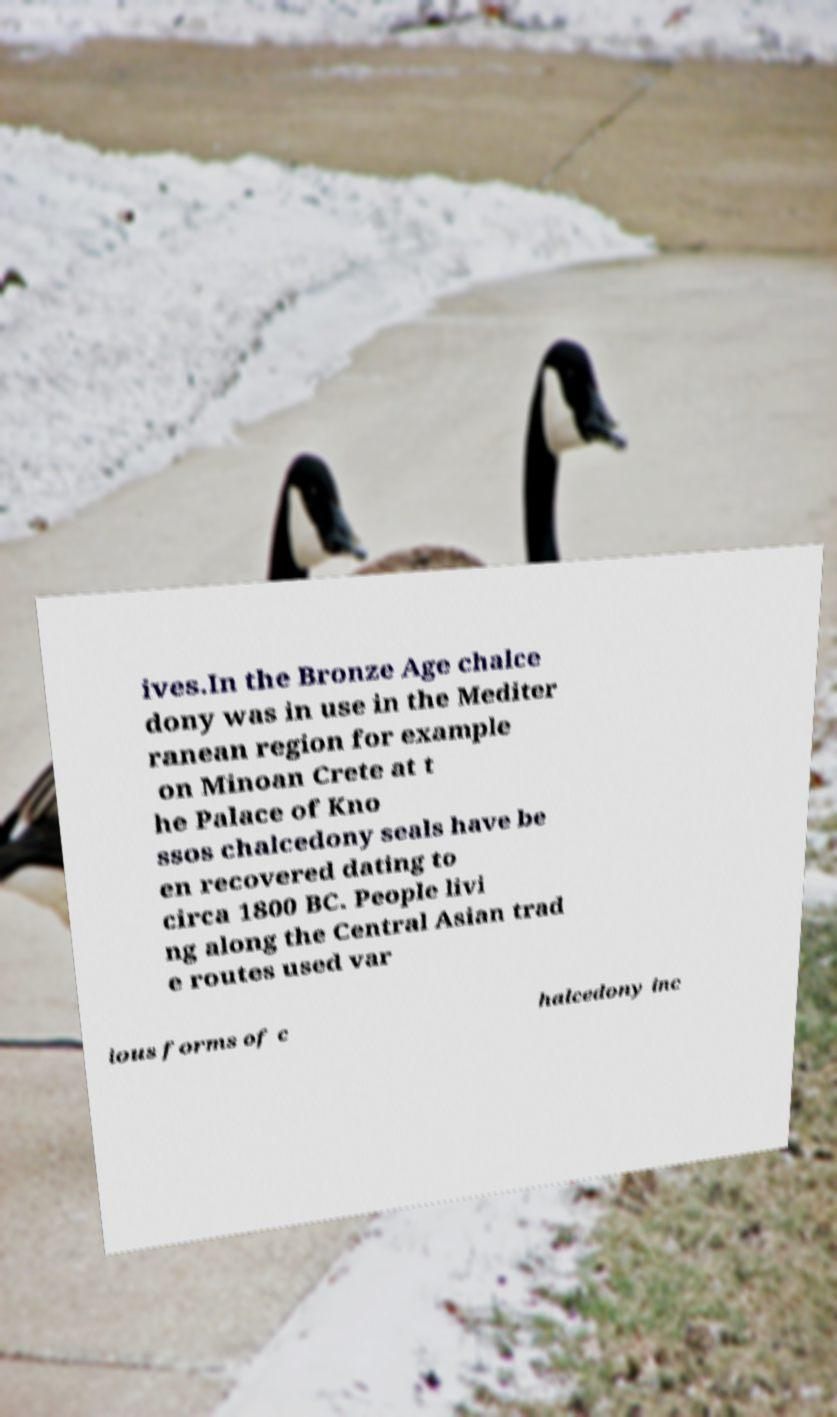For documentation purposes, I need the text within this image transcribed. Could you provide that? ives.In the Bronze Age chalce dony was in use in the Mediter ranean region for example on Minoan Crete at t he Palace of Kno ssos chalcedony seals have be en recovered dating to circa 1800 BC. People livi ng along the Central Asian trad e routes used var ious forms of c halcedony inc 